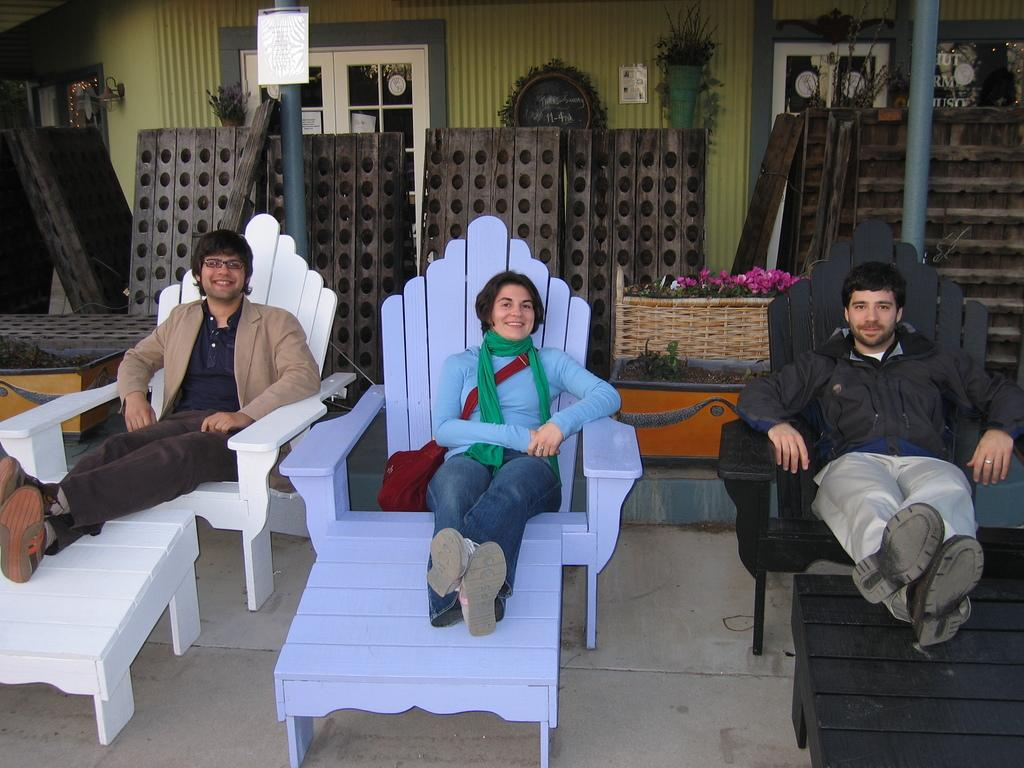How many people are in the image? There are three people in the image: two men and a woman. What are the people doing in the image? The people are sitting on chairs and smiling. What can be seen in the background of the image? There are poles, a wall, and windows in the background of the image. What type of quill is being used by the woman in the image? There is no quill present in the image; the woman is simply sitting and smiling. 